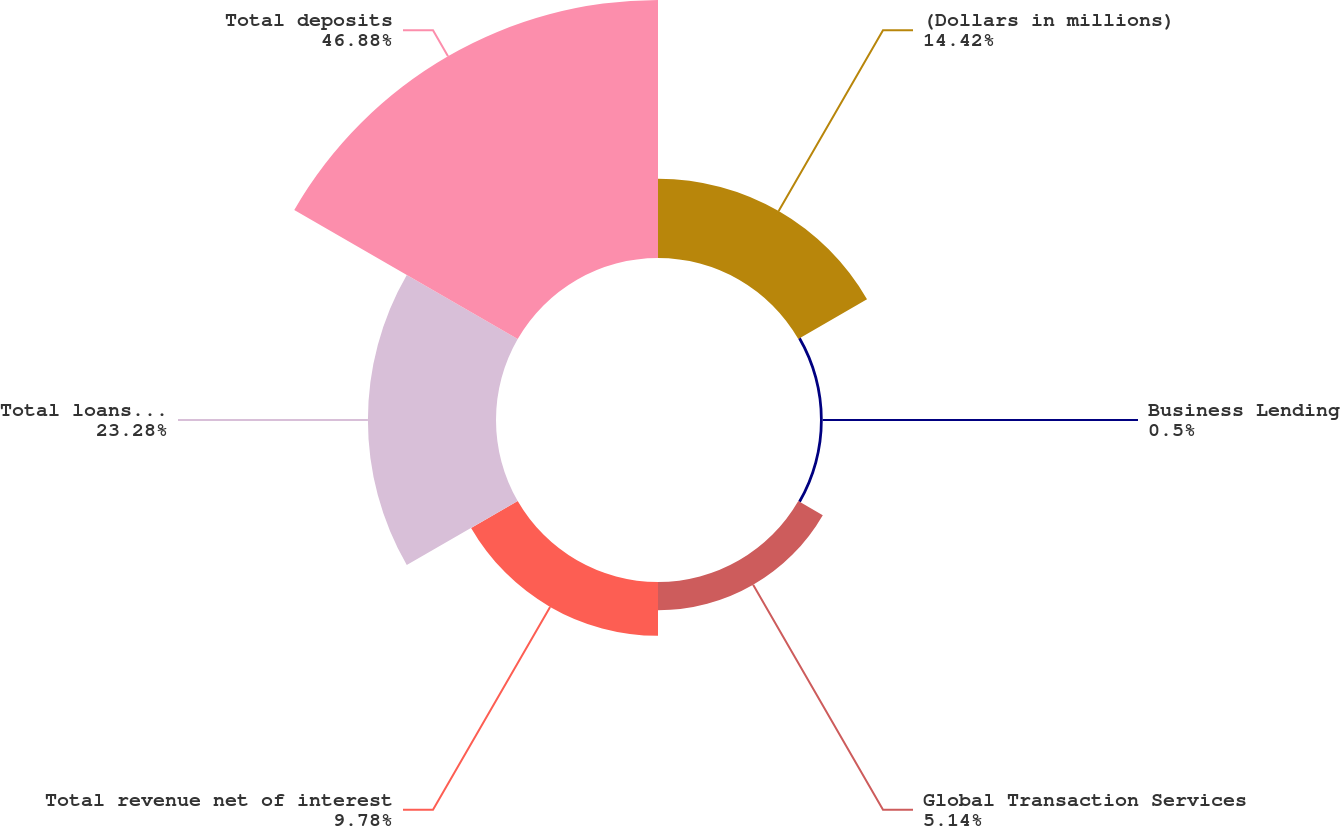Convert chart to OTSL. <chart><loc_0><loc_0><loc_500><loc_500><pie_chart><fcel>(Dollars in millions)<fcel>Business Lending<fcel>Global Transaction Services<fcel>Total revenue net of interest<fcel>Total loans and leases<fcel>Total deposits<nl><fcel>14.42%<fcel>0.5%<fcel>5.14%<fcel>9.78%<fcel>23.28%<fcel>46.89%<nl></chart> 